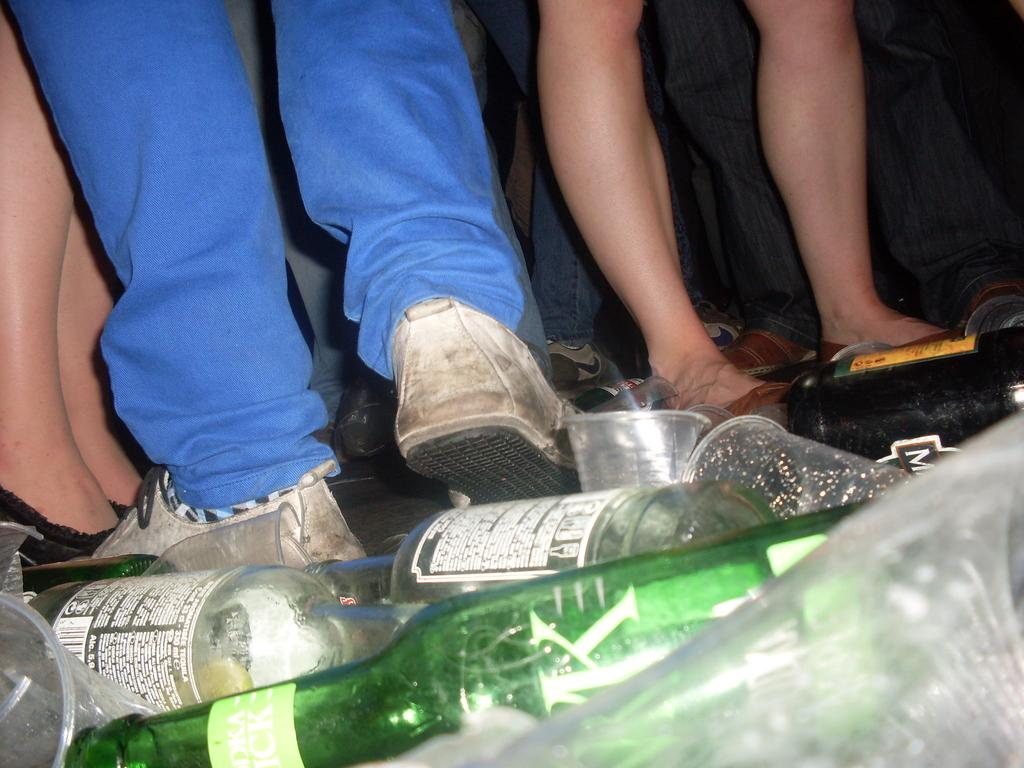What objects are present in large quantities in the image? There are many bottles and glasses in the image. Can you describe the presence of people in the image? The legs of many persons are visible in the image. What type of wrist accessory can be seen on the persons in the image? There is no wrist accessory visible on the persons in the image. What might cause the bottles and glasses to burst in the image? There is no indication of any bottles or glasses bursting in the image. 